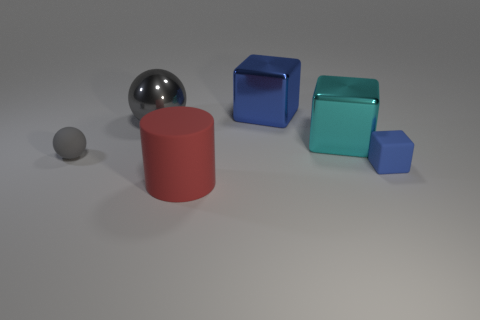Is the color of the shiny ball the same as the matte block?
Make the answer very short. No. What number of things are either small rubber cubes that are to the right of the cylinder or rubber blocks?
Your response must be concise. 1. There is a big cube right of the blue object behind the small matte ball; how many tiny matte things are to the left of it?
Your response must be concise. 1. Is there anything else that is the same size as the cyan object?
Give a very brief answer. Yes. What is the shape of the small thing that is to the right of the gray sphere that is in front of the metal object to the left of the red cylinder?
Offer a very short reply. Cube. What number of other things are the same color as the metal ball?
Give a very brief answer. 1. There is a small rubber object that is to the left of the thing on the right side of the big cyan metal block; what shape is it?
Provide a succinct answer. Sphere. How many blue metallic things are on the left side of the small blue rubber block?
Your response must be concise. 1. Are there any other things made of the same material as the cyan thing?
Offer a terse response. Yes. There is a gray thing that is the same size as the rubber block; what material is it?
Your answer should be very brief. Rubber. 